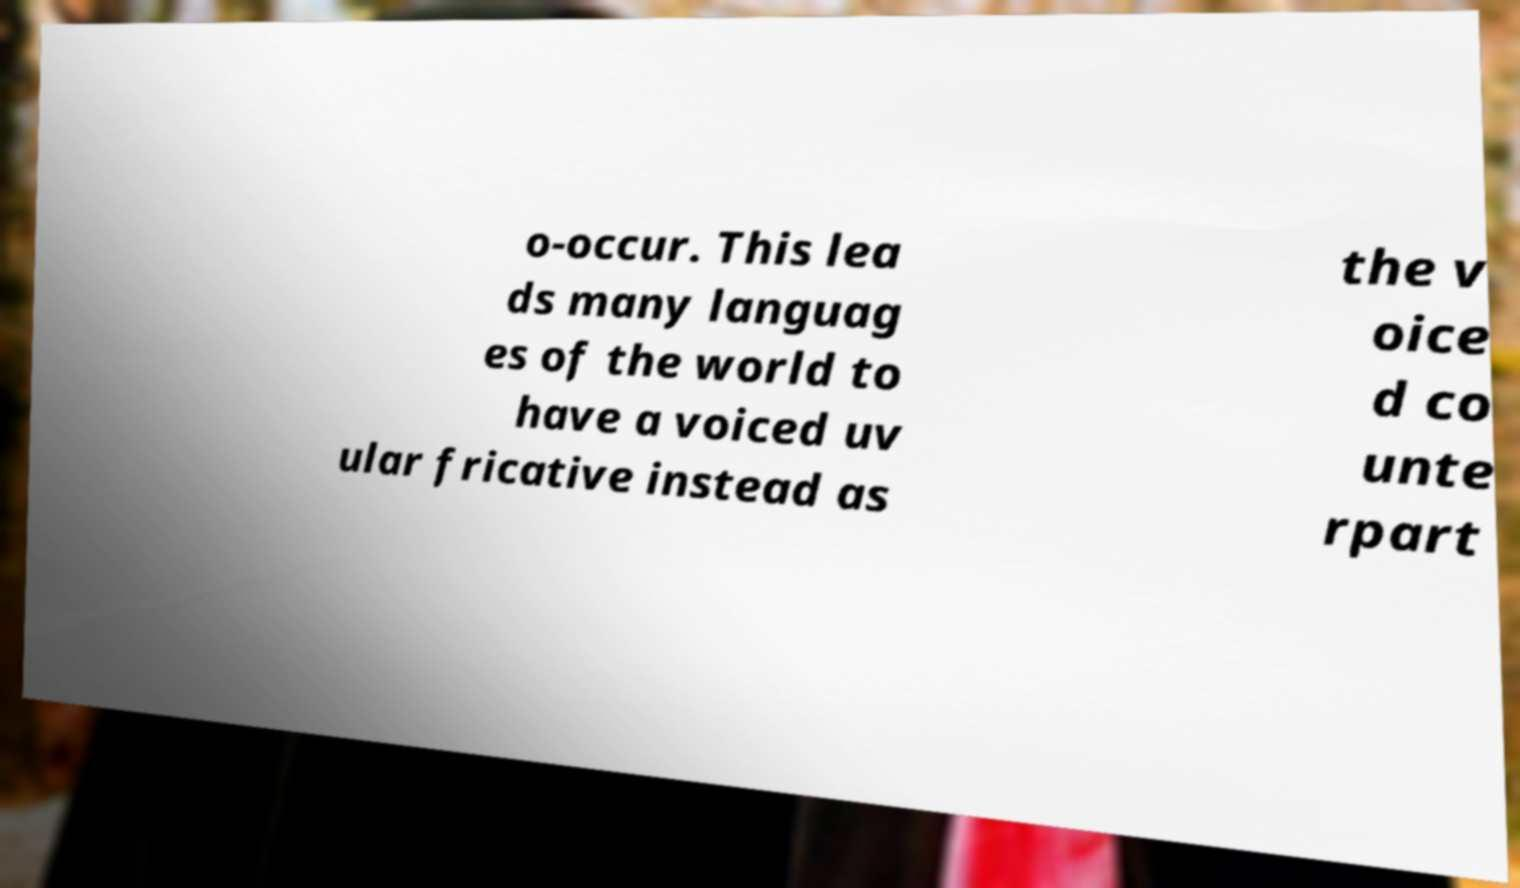For documentation purposes, I need the text within this image transcribed. Could you provide that? o-occur. This lea ds many languag es of the world to have a voiced uv ular fricative instead as the v oice d co unte rpart 